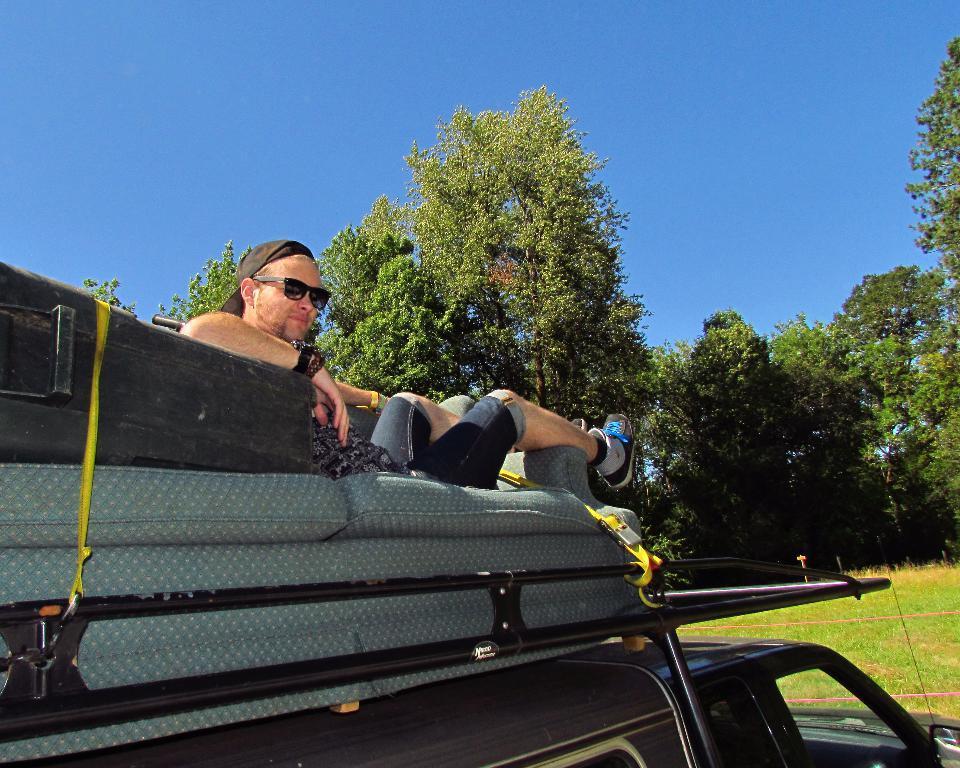How would you summarize this image in a sentence or two? In this image I can see the person sitting on the bed. To the left I can see the black color box. The person and the bed are on the vehicle. The vehicle is in black color. In the back I can see many trees and the blue sky. 